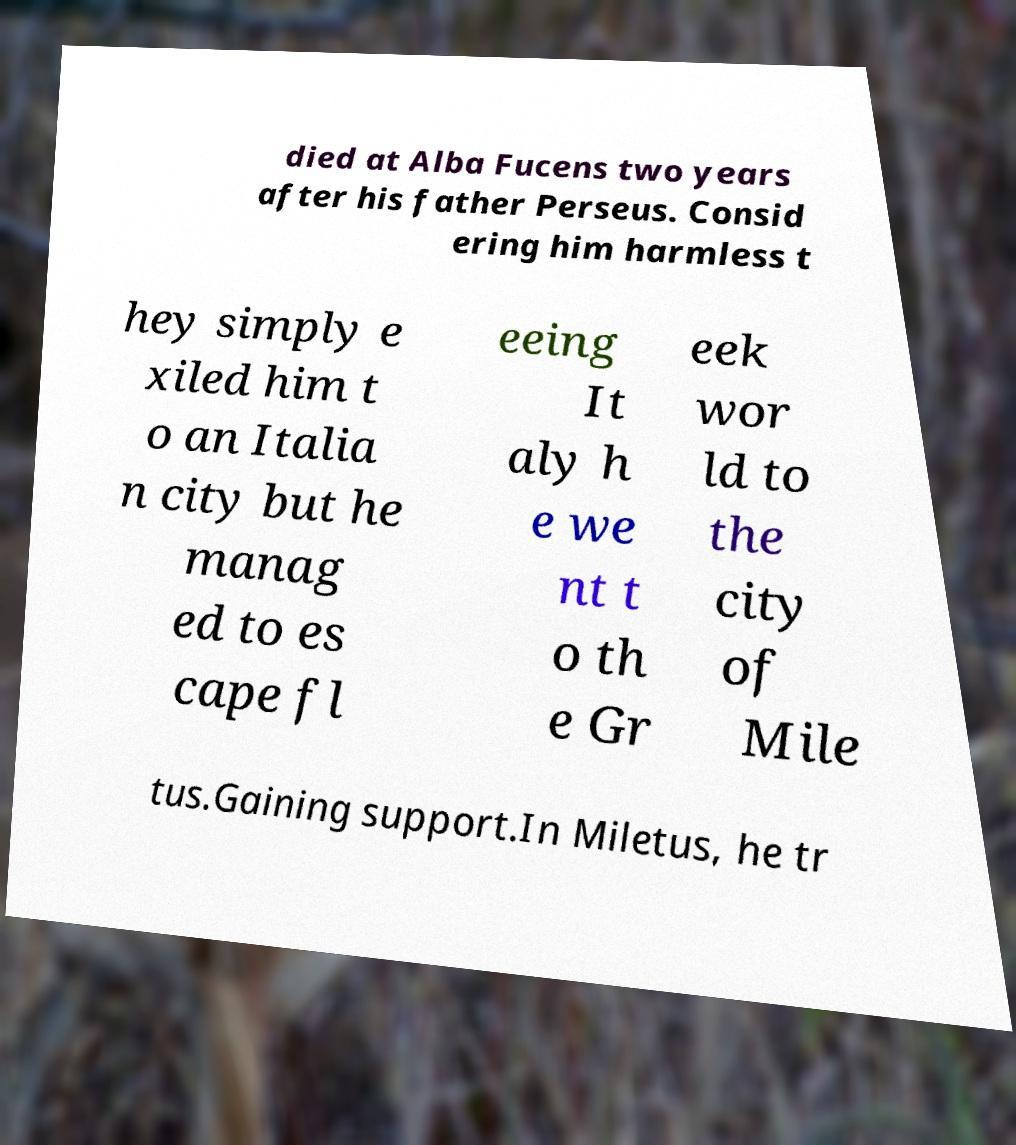Please identify and transcribe the text found in this image. died at Alba Fucens two years after his father Perseus. Consid ering him harmless t hey simply e xiled him t o an Italia n city but he manag ed to es cape fl eeing It aly h e we nt t o th e Gr eek wor ld to the city of Mile tus.Gaining support.In Miletus, he tr 